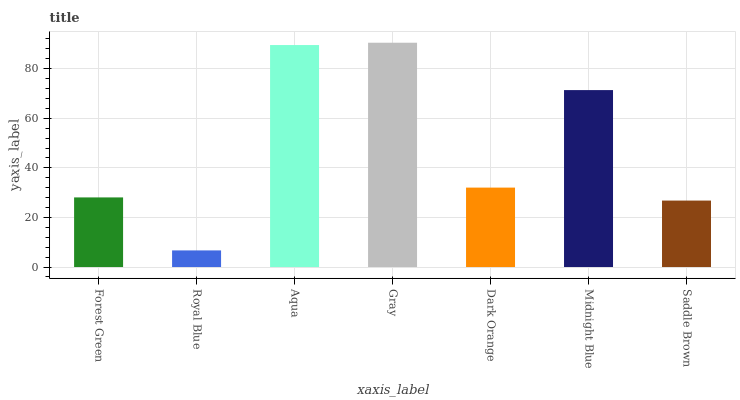Is Aqua the minimum?
Answer yes or no. No. Is Aqua the maximum?
Answer yes or no. No. Is Aqua greater than Royal Blue?
Answer yes or no. Yes. Is Royal Blue less than Aqua?
Answer yes or no. Yes. Is Royal Blue greater than Aqua?
Answer yes or no. No. Is Aqua less than Royal Blue?
Answer yes or no. No. Is Dark Orange the high median?
Answer yes or no. Yes. Is Dark Orange the low median?
Answer yes or no. Yes. Is Forest Green the high median?
Answer yes or no. No. Is Aqua the low median?
Answer yes or no. No. 